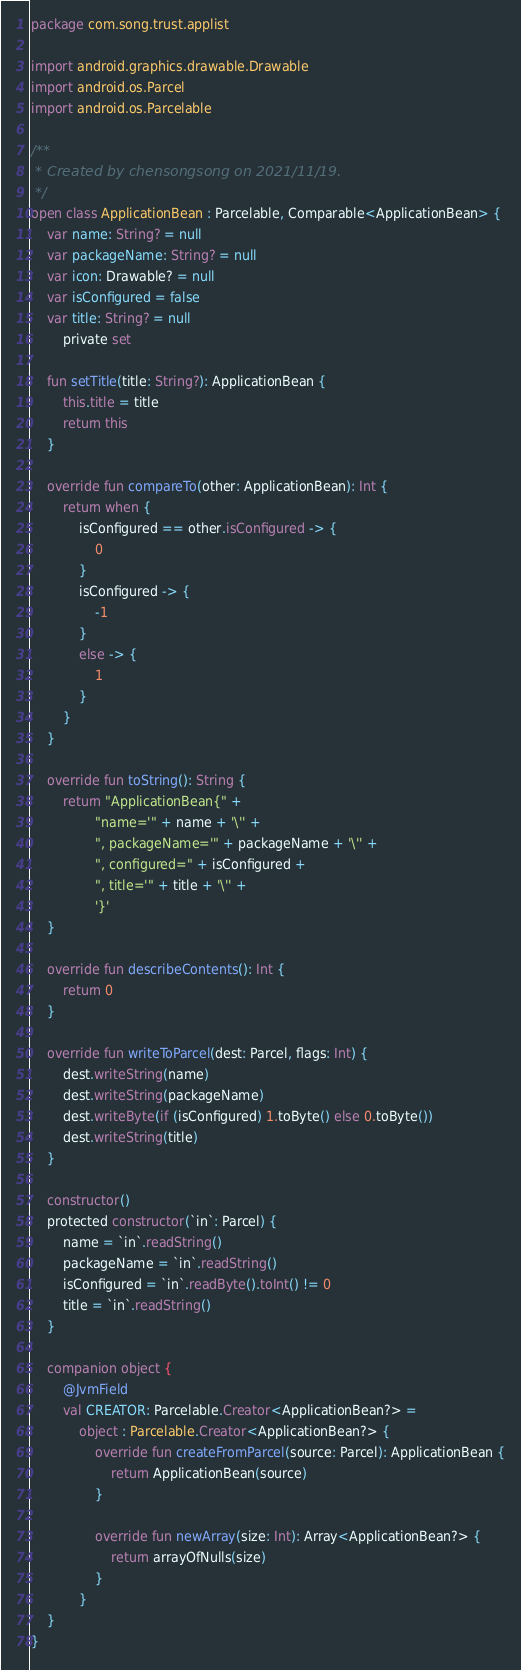Convert code to text. <code><loc_0><loc_0><loc_500><loc_500><_Kotlin_>package com.song.trust.applist

import android.graphics.drawable.Drawable
import android.os.Parcel
import android.os.Parcelable

/**
 * Created by chensongsong on 2021/11/19.
 */
open class ApplicationBean : Parcelable, Comparable<ApplicationBean> {
    var name: String? = null
    var packageName: String? = null
    var icon: Drawable? = null
    var isConfigured = false
    var title: String? = null
        private set

    fun setTitle(title: String?): ApplicationBean {
        this.title = title
        return this
    }

    override fun compareTo(other: ApplicationBean): Int {
        return when {
            isConfigured == other.isConfigured -> {
                0
            }
            isConfigured -> {
                -1
            }
            else -> {
                1
            }
        }
    }

    override fun toString(): String {
        return "ApplicationBean{" +
                "name='" + name + '\'' +
                ", packageName='" + packageName + '\'' +
                ", configured=" + isConfigured +
                ", title='" + title + '\'' +
                '}'
    }

    override fun describeContents(): Int {
        return 0
    }

    override fun writeToParcel(dest: Parcel, flags: Int) {
        dest.writeString(name)
        dest.writeString(packageName)
        dest.writeByte(if (isConfigured) 1.toByte() else 0.toByte())
        dest.writeString(title)
    }

    constructor()
    protected constructor(`in`: Parcel) {
        name = `in`.readString()
        packageName = `in`.readString()
        isConfigured = `in`.readByte().toInt() != 0
        title = `in`.readString()
    }

    companion object {
        @JvmField
        val CREATOR: Parcelable.Creator<ApplicationBean?> =
            object : Parcelable.Creator<ApplicationBean?> {
                override fun createFromParcel(source: Parcel): ApplicationBean {
                    return ApplicationBean(source)
                }

                override fun newArray(size: Int): Array<ApplicationBean?> {
                    return arrayOfNulls(size)
                }
            }
    }
}</code> 